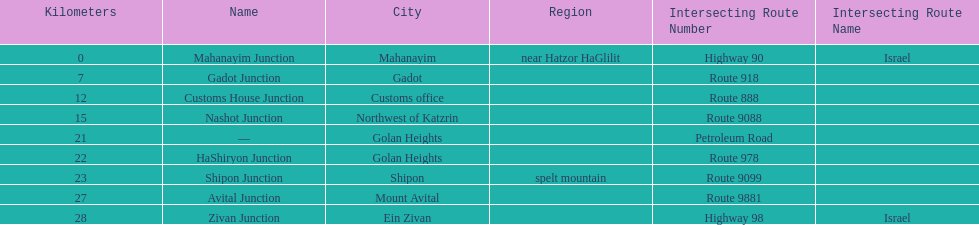Which junction on highway 91 is closer to ein zivan, gadot junction or shipon junction? Gadot Junction. 